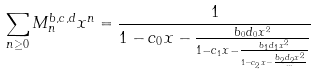Convert formula to latex. <formula><loc_0><loc_0><loc_500><loc_500>\sum _ { n \geq 0 } M _ { n } ^ { b , c , d } x ^ { n } = \frac { 1 } { 1 - c _ { 0 } x - \frac { b _ { 0 } d _ { 0 } x ^ { 2 } } { 1 - c _ { 1 } x - \frac { b _ { 1 } d _ { 1 } x ^ { 2 } } { 1 - c _ { 2 } x - \frac { b _ { 2 } d _ { 2 } x ^ { 2 } } { \cdots } } } }</formula> 